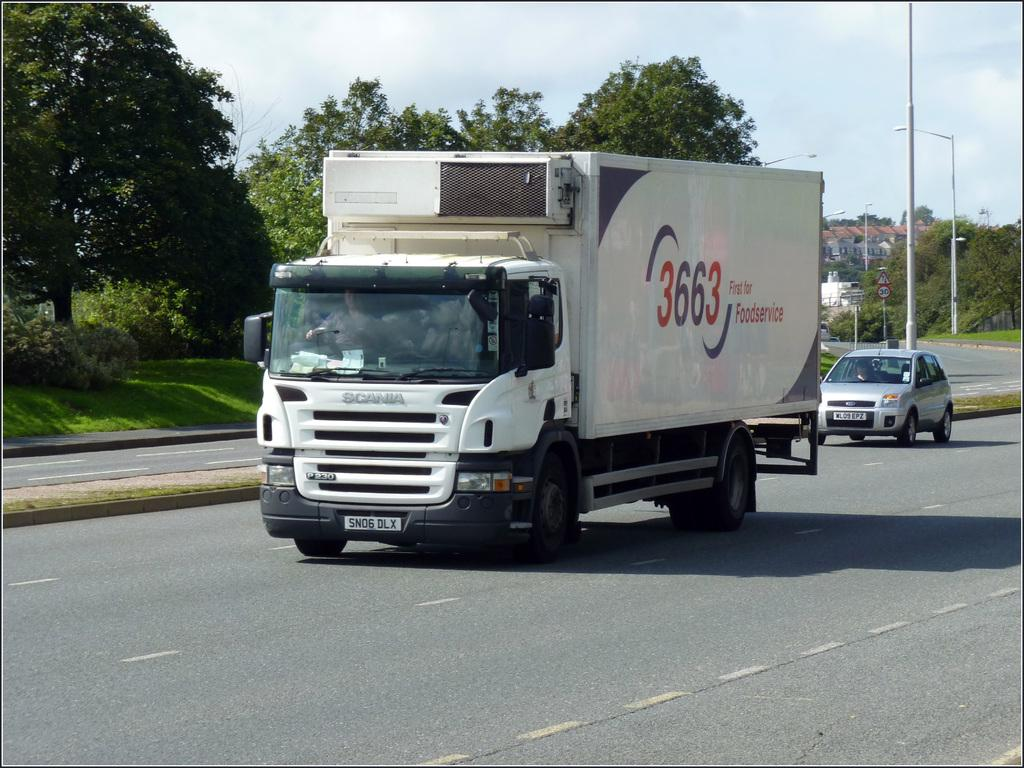What is the main feature of the image? There is a road in the image. What can be seen on the vehicles in the image? There are vehicles with text on them in the image. What objects are present along the road? There are poles in the image. What can be seen in the distance in the image? There are trees, buildings, and clouds in the background of the image. What type of rabbit can be seen cooking a stew in the image? There is no rabbit or stew present in the image. 